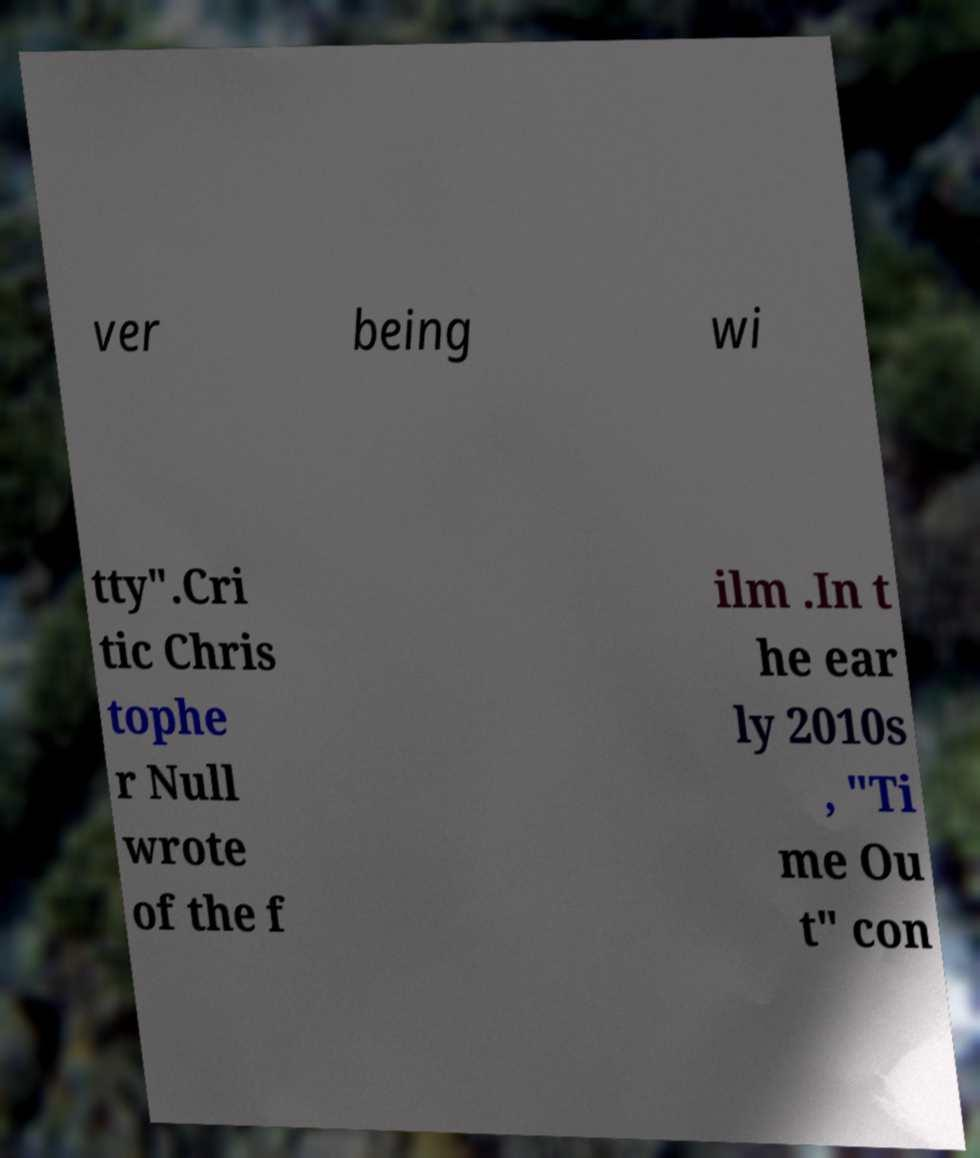Please read and relay the text visible in this image. What does it say? ver being wi tty".Cri tic Chris tophe r Null wrote of the f ilm .In t he ear ly 2010s , "Ti me Ou t" con 